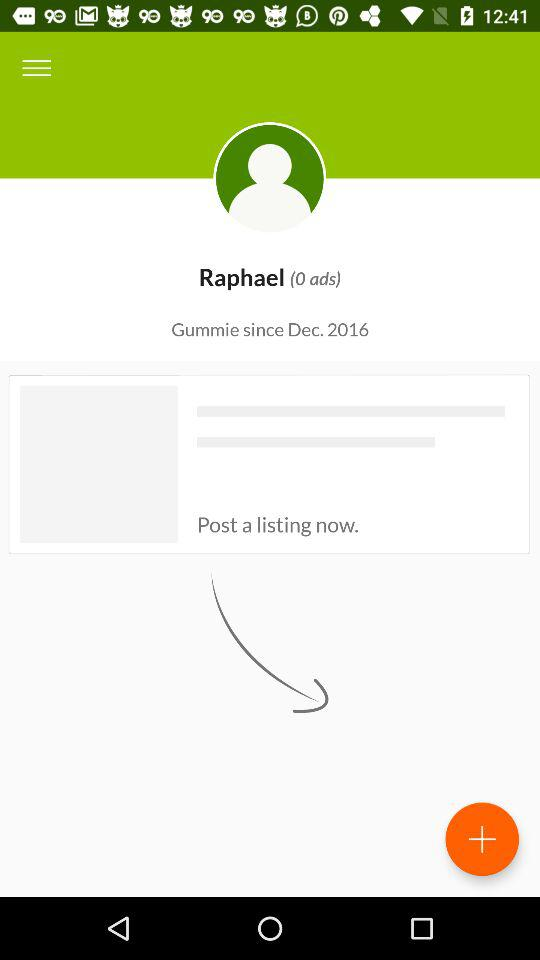How many ads does Raphael have?
Answer the question using a single word or phrase. 0 